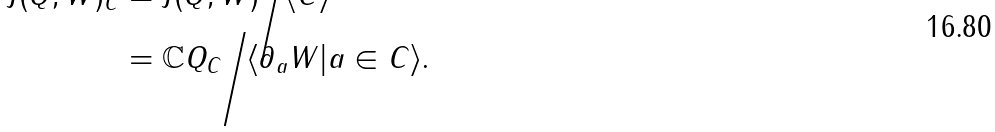Convert formula to latex. <formula><loc_0><loc_0><loc_500><loc_500>J ( Q , W ) _ { C } & = J ( Q , W ) \Big / \langle C \rangle \\ & = \mathbb { C } Q _ { C } \Big / \langle \partial _ { a } W | a \in C \rangle .</formula> 